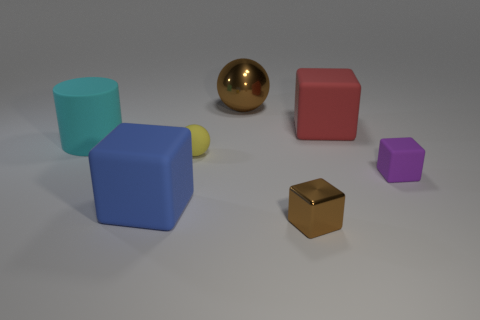Add 2 tiny yellow shiny spheres. How many objects exist? 9 Subtract all cylinders. How many objects are left? 6 Subtract 1 cyan cylinders. How many objects are left? 6 Subtract all tiny brown metallic objects. Subtract all big cyan objects. How many objects are left? 5 Add 5 large blue cubes. How many large blue cubes are left? 6 Add 2 large blue matte cylinders. How many large blue matte cylinders exist? 2 